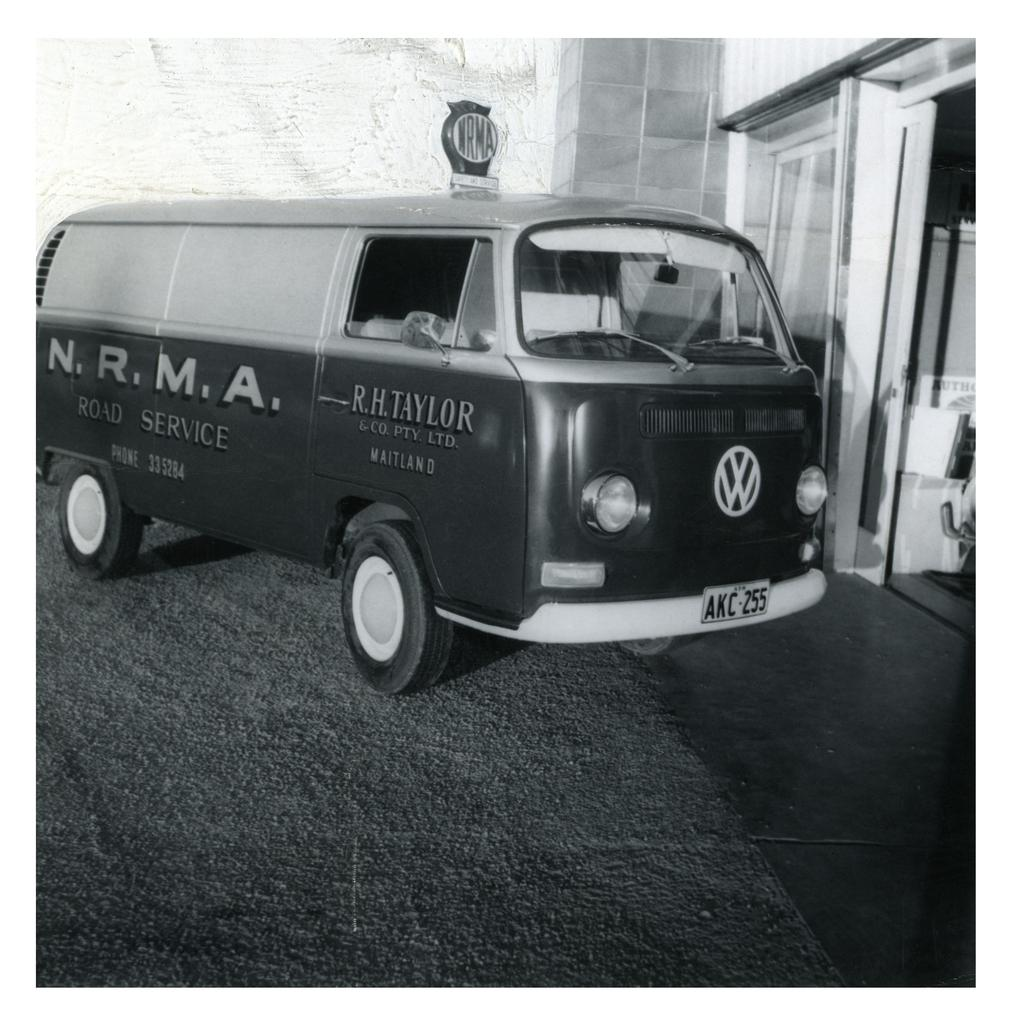<image>
Create a compact narrative representing the image presented. a car that has the letters NRMA on the side 